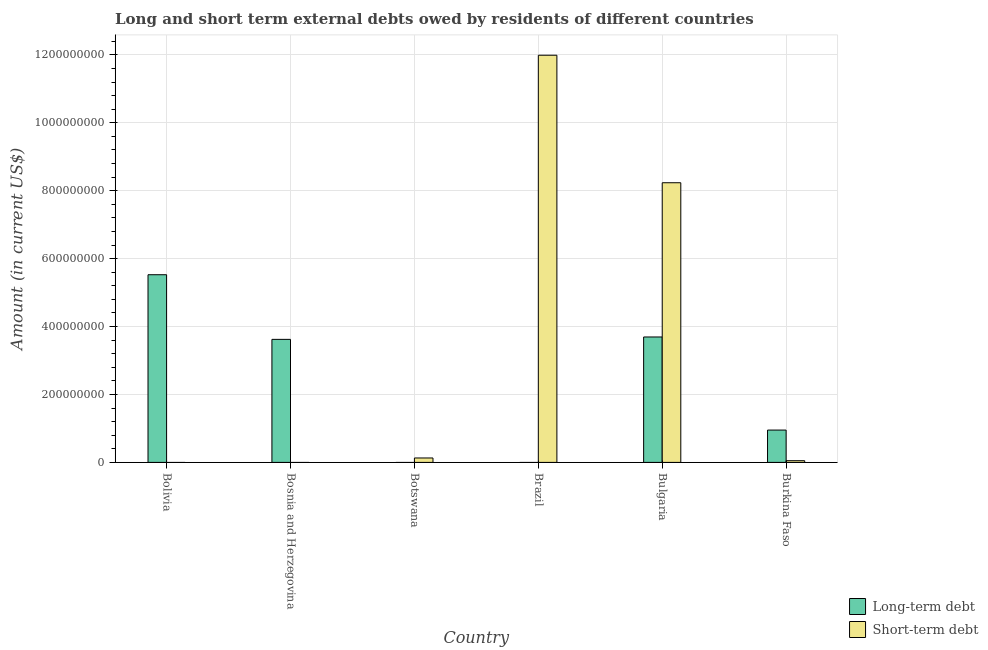Are the number of bars per tick equal to the number of legend labels?
Make the answer very short. No. Are the number of bars on each tick of the X-axis equal?
Your response must be concise. No. How many bars are there on the 5th tick from the left?
Make the answer very short. 2. How many bars are there on the 2nd tick from the right?
Provide a short and direct response. 2. What is the short-term debts owed by residents in Bulgaria?
Give a very brief answer. 8.24e+08. Across all countries, what is the maximum long-term debts owed by residents?
Offer a very short reply. 5.53e+08. What is the total long-term debts owed by residents in the graph?
Your answer should be compact. 1.38e+09. What is the difference between the short-term debts owed by residents in Brazil and that in Burkina Faso?
Keep it short and to the point. 1.19e+09. What is the difference between the long-term debts owed by residents in Bulgaria and the short-term debts owed by residents in Burkina Faso?
Offer a very short reply. 3.64e+08. What is the average long-term debts owed by residents per country?
Your answer should be compact. 2.30e+08. What is the difference between the short-term debts owed by residents and long-term debts owed by residents in Burkina Faso?
Your answer should be very brief. -9.02e+07. In how many countries, is the long-term debts owed by residents greater than 120000000 US$?
Your answer should be compact. 3. What is the ratio of the long-term debts owed by residents in Bolivia to that in Bulgaria?
Your response must be concise. 1.5. Is the long-term debts owed by residents in Bolivia less than that in Burkina Faso?
Provide a short and direct response. No. What is the difference between the highest and the second highest short-term debts owed by residents?
Make the answer very short. 3.76e+08. What is the difference between the highest and the lowest long-term debts owed by residents?
Your answer should be compact. 5.53e+08. How many bars are there?
Give a very brief answer. 8. Are all the bars in the graph horizontal?
Ensure brevity in your answer.  No. How many countries are there in the graph?
Your answer should be compact. 6. What is the difference between two consecutive major ticks on the Y-axis?
Ensure brevity in your answer.  2.00e+08. Does the graph contain any zero values?
Offer a terse response. Yes. How are the legend labels stacked?
Provide a short and direct response. Vertical. What is the title of the graph?
Give a very brief answer. Long and short term external debts owed by residents of different countries. What is the label or title of the Y-axis?
Make the answer very short. Amount (in current US$). What is the Amount (in current US$) of Long-term debt in Bolivia?
Your answer should be very brief. 5.53e+08. What is the Amount (in current US$) in Short-term debt in Bolivia?
Provide a short and direct response. 0. What is the Amount (in current US$) in Long-term debt in Bosnia and Herzegovina?
Make the answer very short. 3.62e+08. What is the Amount (in current US$) in Short-term debt in Bosnia and Herzegovina?
Your response must be concise. 0. What is the Amount (in current US$) in Short-term debt in Botswana?
Make the answer very short. 1.30e+07. What is the Amount (in current US$) of Long-term debt in Brazil?
Make the answer very short. 0. What is the Amount (in current US$) in Short-term debt in Brazil?
Keep it short and to the point. 1.20e+09. What is the Amount (in current US$) in Long-term debt in Bulgaria?
Keep it short and to the point. 3.69e+08. What is the Amount (in current US$) in Short-term debt in Bulgaria?
Make the answer very short. 8.24e+08. What is the Amount (in current US$) in Long-term debt in Burkina Faso?
Your answer should be compact. 9.52e+07. What is the Amount (in current US$) of Short-term debt in Burkina Faso?
Offer a terse response. 5.00e+06. Across all countries, what is the maximum Amount (in current US$) in Long-term debt?
Your answer should be compact. 5.53e+08. Across all countries, what is the maximum Amount (in current US$) of Short-term debt?
Your answer should be very brief. 1.20e+09. Across all countries, what is the minimum Amount (in current US$) in Long-term debt?
Provide a short and direct response. 0. What is the total Amount (in current US$) of Long-term debt in the graph?
Give a very brief answer. 1.38e+09. What is the total Amount (in current US$) in Short-term debt in the graph?
Offer a terse response. 2.04e+09. What is the difference between the Amount (in current US$) in Long-term debt in Bolivia and that in Bosnia and Herzegovina?
Give a very brief answer. 1.90e+08. What is the difference between the Amount (in current US$) in Long-term debt in Bolivia and that in Bulgaria?
Your answer should be very brief. 1.83e+08. What is the difference between the Amount (in current US$) of Long-term debt in Bolivia and that in Burkina Faso?
Provide a succinct answer. 4.57e+08. What is the difference between the Amount (in current US$) in Long-term debt in Bosnia and Herzegovina and that in Bulgaria?
Your response must be concise. -7.05e+06. What is the difference between the Amount (in current US$) of Long-term debt in Bosnia and Herzegovina and that in Burkina Faso?
Provide a succinct answer. 2.67e+08. What is the difference between the Amount (in current US$) in Short-term debt in Botswana and that in Brazil?
Offer a terse response. -1.19e+09. What is the difference between the Amount (in current US$) of Short-term debt in Botswana and that in Bulgaria?
Offer a terse response. -8.10e+08. What is the difference between the Amount (in current US$) in Short-term debt in Brazil and that in Bulgaria?
Provide a short and direct response. 3.76e+08. What is the difference between the Amount (in current US$) in Short-term debt in Brazil and that in Burkina Faso?
Keep it short and to the point. 1.19e+09. What is the difference between the Amount (in current US$) of Long-term debt in Bulgaria and that in Burkina Faso?
Provide a short and direct response. 2.74e+08. What is the difference between the Amount (in current US$) in Short-term debt in Bulgaria and that in Burkina Faso?
Make the answer very short. 8.18e+08. What is the difference between the Amount (in current US$) of Long-term debt in Bolivia and the Amount (in current US$) of Short-term debt in Botswana?
Offer a terse response. 5.40e+08. What is the difference between the Amount (in current US$) in Long-term debt in Bolivia and the Amount (in current US$) in Short-term debt in Brazil?
Ensure brevity in your answer.  -6.46e+08. What is the difference between the Amount (in current US$) of Long-term debt in Bolivia and the Amount (in current US$) of Short-term debt in Bulgaria?
Provide a succinct answer. -2.71e+08. What is the difference between the Amount (in current US$) of Long-term debt in Bolivia and the Amount (in current US$) of Short-term debt in Burkina Faso?
Keep it short and to the point. 5.48e+08. What is the difference between the Amount (in current US$) in Long-term debt in Bosnia and Herzegovina and the Amount (in current US$) in Short-term debt in Botswana?
Make the answer very short. 3.49e+08. What is the difference between the Amount (in current US$) in Long-term debt in Bosnia and Herzegovina and the Amount (in current US$) in Short-term debt in Brazil?
Your answer should be compact. -8.37e+08. What is the difference between the Amount (in current US$) of Long-term debt in Bosnia and Herzegovina and the Amount (in current US$) of Short-term debt in Bulgaria?
Your answer should be compact. -4.61e+08. What is the difference between the Amount (in current US$) of Long-term debt in Bosnia and Herzegovina and the Amount (in current US$) of Short-term debt in Burkina Faso?
Your answer should be compact. 3.57e+08. What is the difference between the Amount (in current US$) in Long-term debt in Bulgaria and the Amount (in current US$) in Short-term debt in Burkina Faso?
Ensure brevity in your answer.  3.64e+08. What is the average Amount (in current US$) in Long-term debt per country?
Ensure brevity in your answer.  2.30e+08. What is the average Amount (in current US$) in Short-term debt per country?
Keep it short and to the point. 3.40e+08. What is the difference between the Amount (in current US$) in Long-term debt and Amount (in current US$) in Short-term debt in Bulgaria?
Give a very brief answer. -4.54e+08. What is the difference between the Amount (in current US$) in Long-term debt and Amount (in current US$) in Short-term debt in Burkina Faso?
Make the answer very short. 9.02e+07. What is the ratio of the Amount (in current US$) of Long-term debt in Bolivia to that in Bosnia and Herzegovina?
Give a very brief answer. 1.53. What is the ratio of the Amount (in current US$) of Long-term debt in Bolivia to that in Bulgaria?
Ensure brevity in your answer.  1.5. What is the ratio of the Amount (in current US$) of Long-term debt in Bolivia to that in Burkina Faso?
Provide a short and direct response. 5.81. What is the ratio of the Amount (in current US$) in Long-term debt in Bosnia and Herzegovina to that in Bulgaria?
Make the answer very short. 0.98. What is the ratio of the Amount (in current US$) of Long-term debt in Bosnia and Herzegovina to that in Burkina Faso?
Make the answer very short. 3.81. What is the ratio of the Amount (in current US$) in Short-term debt in Botswana to that in Brazil?
Your answer should be very brief. 0.01. What is the ratio of the Amount (in current US$) in Short-term debt in Botswana to that in Bulgaria?
Keep it short and to the point. 0.02. What is the ratio of the Amount (in current US$) of Short-term debt in Brazil to that in Bulgaria?
Give a very brief answer. 1.46. What is the ratio of the Amount (in current US$) in Short-term debt in Brazil to that in Burkina Faso?
Your answer should be compact. 239.8. What is the ratio of the Amount (in current US$) in Long-term debt in Bulgaria to that in Burkina Faso?
Offer a terse response. 3.88. What is the ratio of the Amount (in current US$) of Short-term debt in Bulgaria to that in Burkina Faso?
Offer a very short reply. 164.7. What is the difference between the highest and the second highest Amount (in current US$) in Long-term debt?
Offer a terse response. 1.83e+08. What is the difference between the highest and the second highest Amount (in current US$) of Short-term debt?
Your answer should be compact. 3.76e+08. What is the difference between the highest and the lowest Amount (in current US$) in Long-term debt?
Your answer should be compact. 5.53e+08. What is the difference between the highest and the lowest Amount (in current US$) of Short-term debt?
Give a very brief answer. 1.20e+09. 